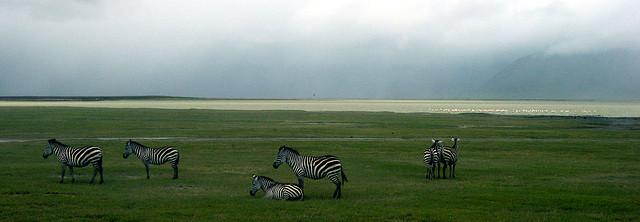What is on the grass? zebras 